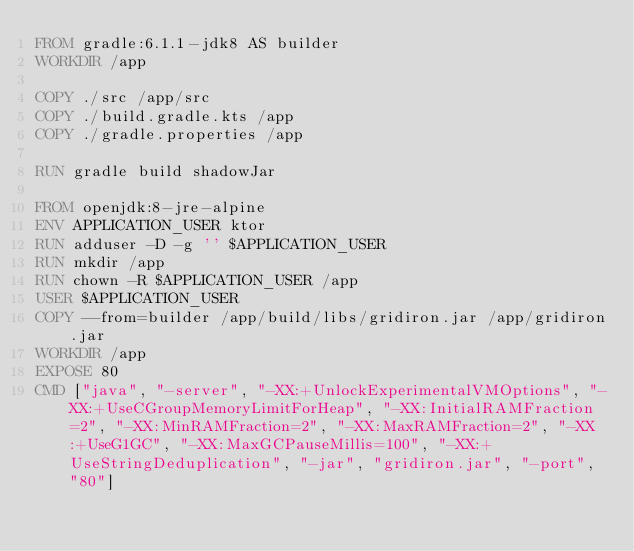Convert code to text. <code><loc_0><loc_0><loc_500><loc_500><_Dockerfile_>FROM gradle:6.1.1-jdk8 AS builder
WORKDIR /app

COPY ./src /app/src
COPY ./build.gradle.kts /app
COPY ./gradle.properties /app

RUN gradle build shadowJar

FROM openjdk:8-jre-alpine
ENV APPLICATION_USER ktor
RUN adduser -D -g '' $APPLICATION_USER
RUN mkdir /app
RUN chown -R $APPLICATION_USER /app
USER $APPLICATION_USER
COPY --from=builder /app/build/libs/gridiron.jar /app/gridiron.jar
WORKDIR /app
EXPOSE 80
CMD ["java", "-server", "-XX:+UnlockExperimentalVMOptions", "-XX:+UseCGroupMemoryLimitForHeap", "-XX:InitialRAMFraction=2", "-XX:MinRAMFraction=2", "-XX:MaxRAMFraction=2", "-XX:+UseG1GC", "-XX:MaxGCPauseMillis=100", "-XX:+UseStringDeduplication", "-jar", "gridiron.jar", "-port", "80"]
</code> 